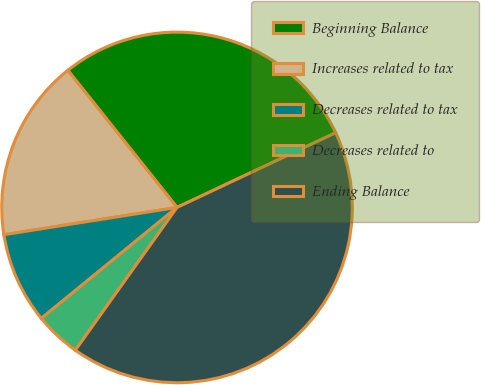<chart> <loc_0><loc_0><loc_500><loc_500><pie_chart><fcel>Beginning Balance<fcel>Increases related to tax<fcel>Decreases related to tax<fcel>Decreases related to<fcel>Ending Balance<nl><fcel>28.7%<fcel>16.78%<fcel>8.42%<fcel>4.24%<fcel>41.85%<nl></chart> 